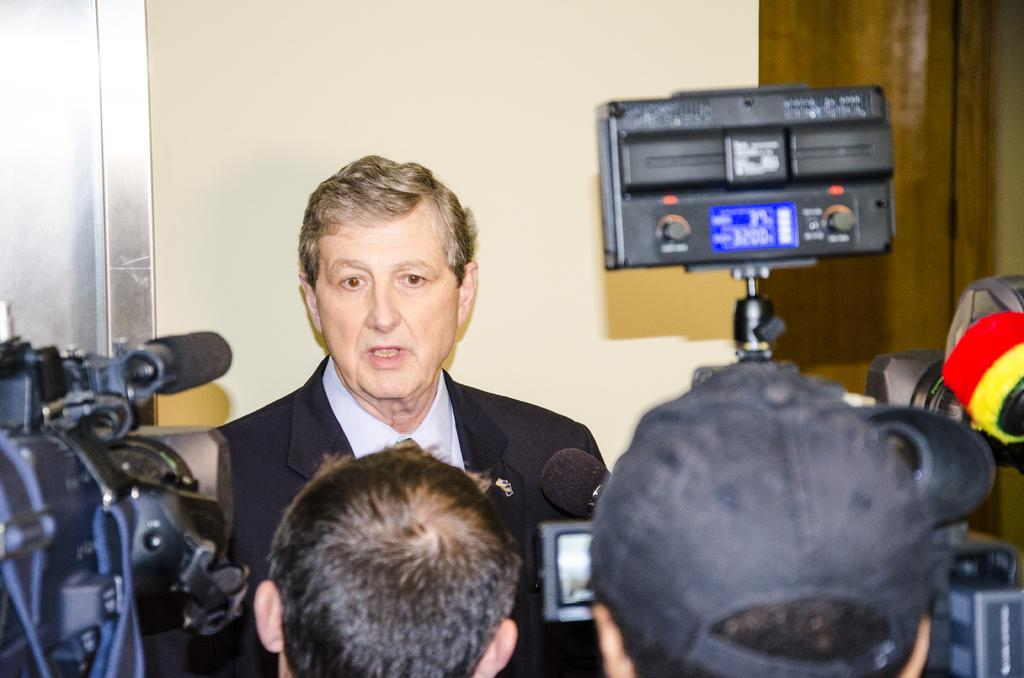What are the people in the image holding? The people in the image are holding cameras and mics. What is happening in the image? There is a man in front of the people holding cameras and mics, suggesting that he might be the subject of their attention is focused on. What can be seen in the background of the image? There is a wall visible in the background of the image. How much payment is being exchanged between the people in the image? There is no indication of payment being exchanged in the image. What type of clocks are hanging on the wall in the image? There are no clocks visible on the wall in the image. 